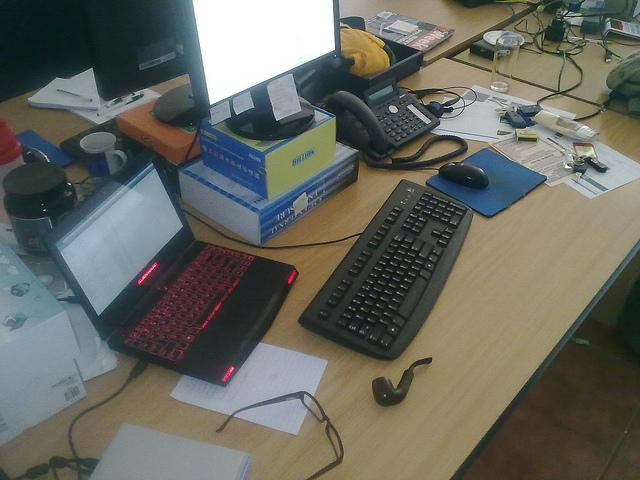What type of phone can this person use at the desk? Please explain your reasoning. landline. The person could use a landline phone. 